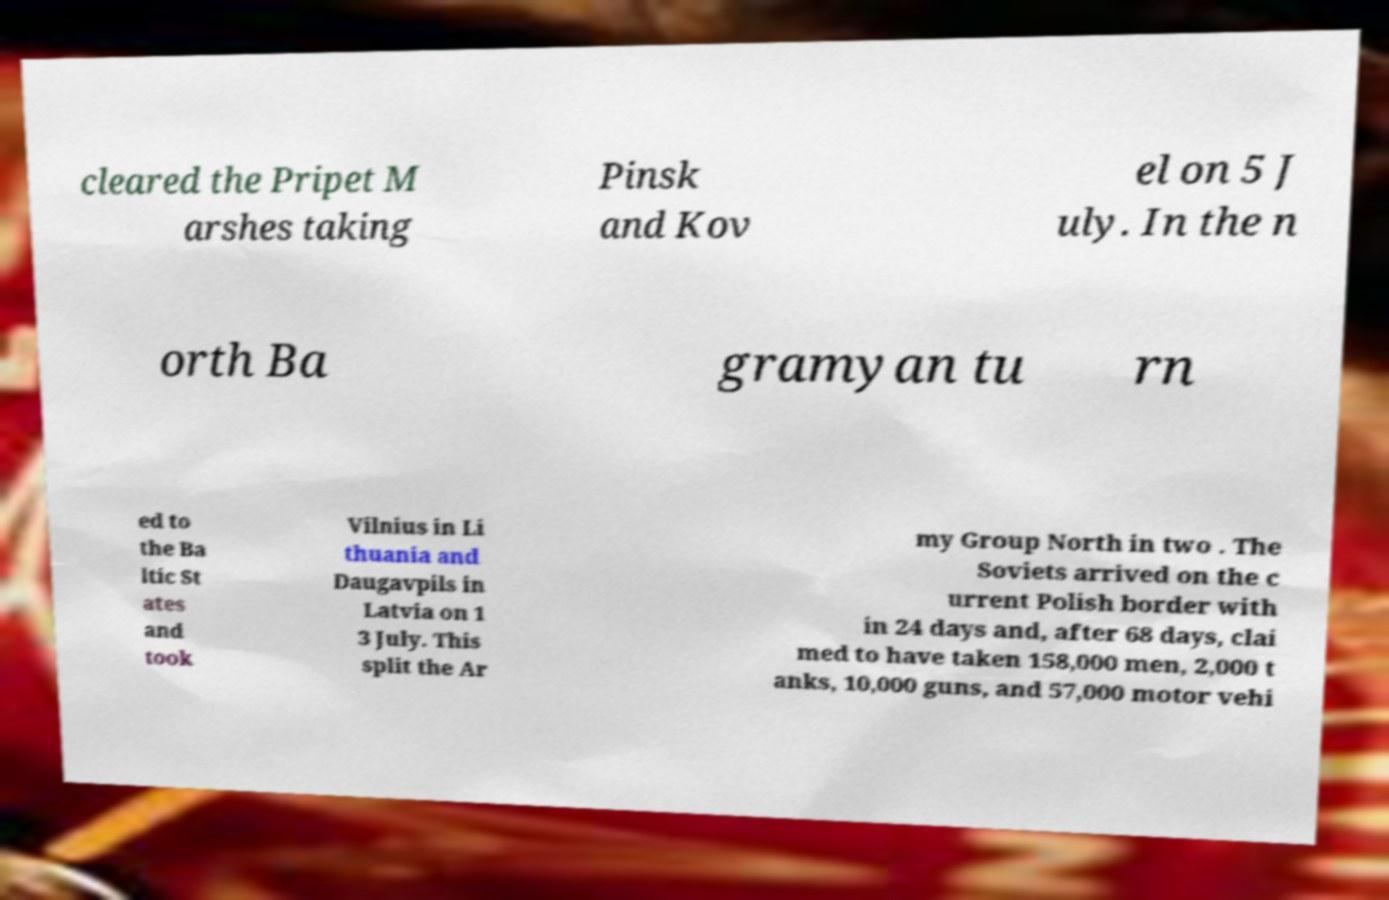There's text embedded in this image that I need extracted. Can you transcribe it verbatim? cleared the Pripet M arshes taking Pinsk and Kov el on 5 J uly. In the n orth Ba gramyan tu rn ed to the Ba ltic St ates and took Vilnius in Li thuania and Daugavpils in Latvia on 1 3 July. This split the Ar my Group North in two . The Soviets arrived on the c urrent Polish border with in 24 days and, after 68 days, clai med to have taken 158,000 men, 2,000 t anks, 10,000 guns, and 57,000 motor vehi 